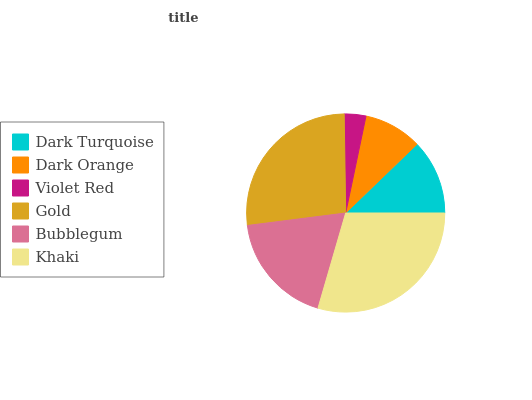Is Violet Red the minimum?
Answer yes or no. Yes. Is Khaki the maximum?
Answer yes or no. Yes. Is Dark Orange the minimum?
Answer yes or no. No. Is Dark Orange the maximum?
Answer yes or no. No. Is Dark Turquoise greater than Dark Orange?
Answer yes or no. Yes. Is Dark Orange less than Dark Turquoise?
Answer yes or no. Yes. Is Dark Orange greater than Dark Turquoise?
Answer yes or no. No. Is Dark Turquoise less than Dark Orange?
Answer yes or no. No. Is Bubblegum the high median?
Answer yes or no. Yes. Is Dark Turquoise the low median?
Answer yes or no. Yes. Is Dark Turquoise the high median?
Answer yes or no. No. Is Dark Orange the low median?
Answer yes or no. No. 